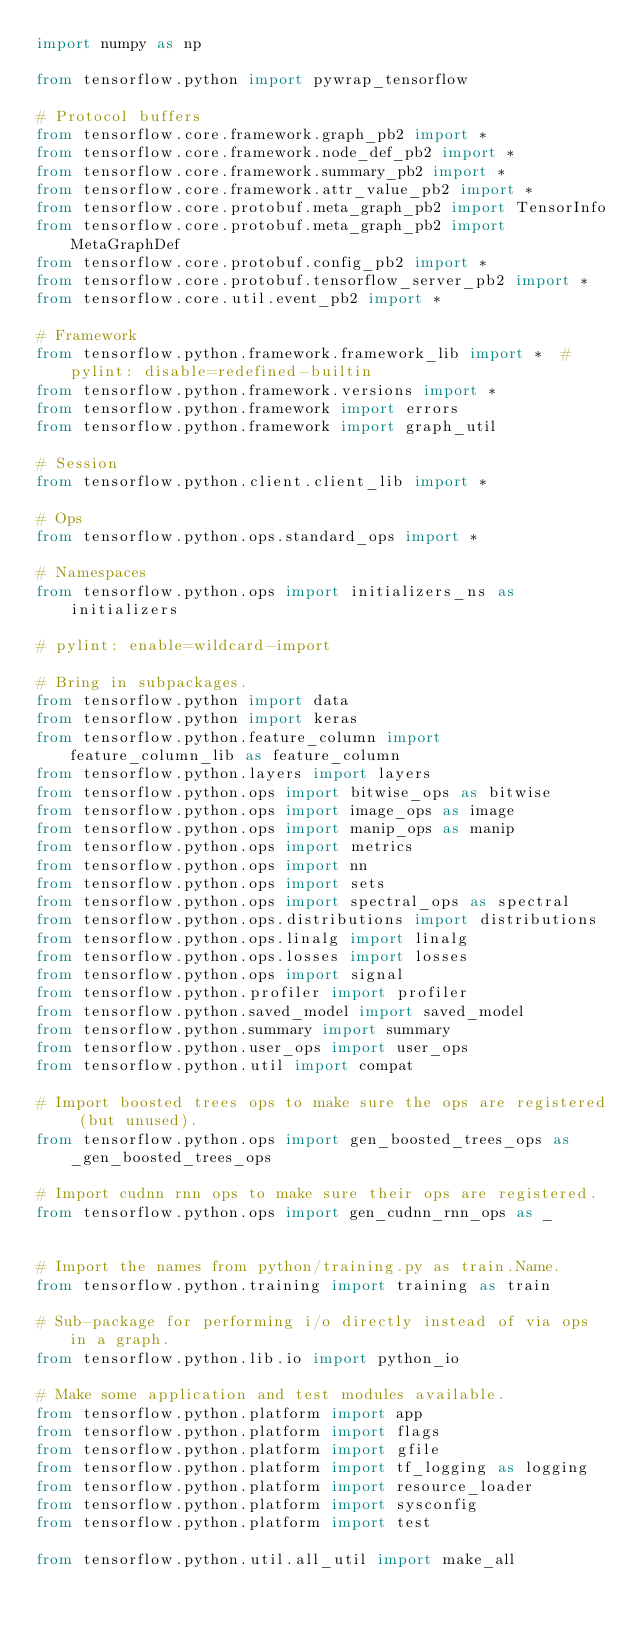<code> <loc_0><loc_0><loc_500><loc_500><_Python_>import numpy as np

from tensorflow.python import pywrap_tensorflow

# Protocol buffers
from tensorflow.core.framework.graph_pb2 import *
from tensorflow.core.framework.node_def_pb2 import *
from tensorflow.core.framework.summary_pb2 import *
from tensorflow.core.framework.attr_value_pb2 import *
from tensorflow.core.protobuf.meta_graph_pb2 import TensorInfo
from tensorflow.core.protobuf.meta_graph_pb2 import MetaGraphDef
from tensorflow.core.protobuf.config_pb2 import *
from tensorflow.core.protobuf.tensorflow_server_pb2 import *
from tensorflow.core.util.event_pb2 import *

# Framework
from tensorflow.python.framework.framework_lib import *  # pylint: disable=redefined-builtin
from tensorflow.python.framework.versions import *
from tensorflow.python.framework import errors
from tensorflow.python.framework import graph_util

# Session
from tensorflow.python.client.client_lib import *

# Ops
from tensorflow.python.ops.standard_ops import *

# Namespaces
from tensorflow.python.ops import initializers_ns as initializers

# pylint: enable=wildcard-import

# Bring in subpackages.
from tensorflow.python import data
from tensorflow.python import keras
from tensorflow.python.feature_column import feature_column_lib as feature_column
from tensorflow.python.layers import layers
from tensorflow.python.ops import bitwise_ops as bitwise
from tensorflow.python.ops import image_ops as image
from tensorflow.python.ops import manip_ops as manip
from tensorflow.python.ops import metrics
from tensorflow.python.ops import nn
from tensorflow.python.ops import sets
from tensorflow.python.ops import spectral_ops as spectral
from tensorflow.python.ops.distributions import distributions
from tensorflow.python.ops.linalg import linalg
from tensorflow.python.ops.losses import losses
from tensorflow.python.ops import signal
from tensorflow.python.profiler import profiler
from tensorflow.python.saved_model import saved_model
from tensorflow.python.summary import summary
from tensorflow.python.user_ops import user_ops
from tensorflow.python.util import compat

# Import boosted trees ops to make sure the ops are registered (but unused).
from tensorflow.python.ops import gen_boosted_trees_ops as _gen_boosted_trees_ops

# Import cudnn rnn ops to make sure their ops are registered.
from tensorflow.python.ops import gen_cudnn_rnn_ops as _


# Import the names from python/training.py as train.Name.
from tensorflow.python.training import training as train

# Sub-package for performing i/o directly instead of via ops in a graph.
from tensorflow.python.lib.io import python_io

# Make some application and test modules available.
from tensorflow.python.platform import app
from tensorflow.python.platform import flags
from tensorflow.python.platform import gfile
from tensorflow.python.platform import tf_logging as logging
from tensorflow.python.platform import resource_loader
from tensorflow.python.platform import sysconfig
from tensorflow.python.platform import test

from tensorflow.python.util.all_util import make_all</code> 